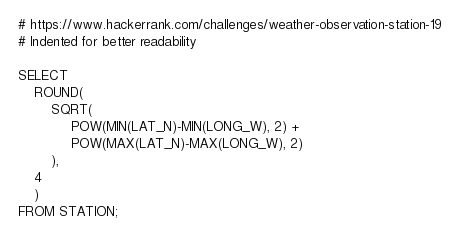<code> <loc_0><loc_0><loc_500><loc_500><_SQL_># https://www.hackerrank.com/challenges/weather-observation-station-19
# Indented for better readability

SELECT 
    ROUND(
        SQRT(
             POW(MIN(LAT_N)-MIN(LONG_W), 2) +
             POW(MAX(LAT_N)-MAX(LONG_W), 2)
        ),
    4
    )
FROM STATION;
</code> 